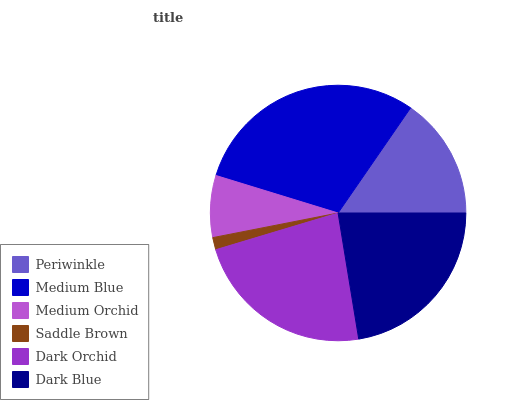Is Saddle Brown the minimum?
Answer yes or no. Yes. Is Medium Blue the maximum?
Answer yes or no. Yes. Is Medium Orchid the minimum?
Answer yes or no. No. Is Medium Orchid the maximum?
Answer yes or no. No. Is Medium Blue greater than Medium Orchid?
Answer yes or no. Yes. Is Medium Orchid less than Medium Blue?
Answer yes or no. Yes. Is Medium Orchid greater than Medium Blue?
Answer yes or no. No. Is Medium Blue less than Medium Orchid?
Answer yes or no. No. Is Dark Blue the high median?
Answer yes or no. Yes. Is Periwinkle the low median?
Answer yes or no. Yes. Is Periwinkle the high median?
Answer yes or no. No. Is Saddle Brown the low median?
Answer yes or no. No. 